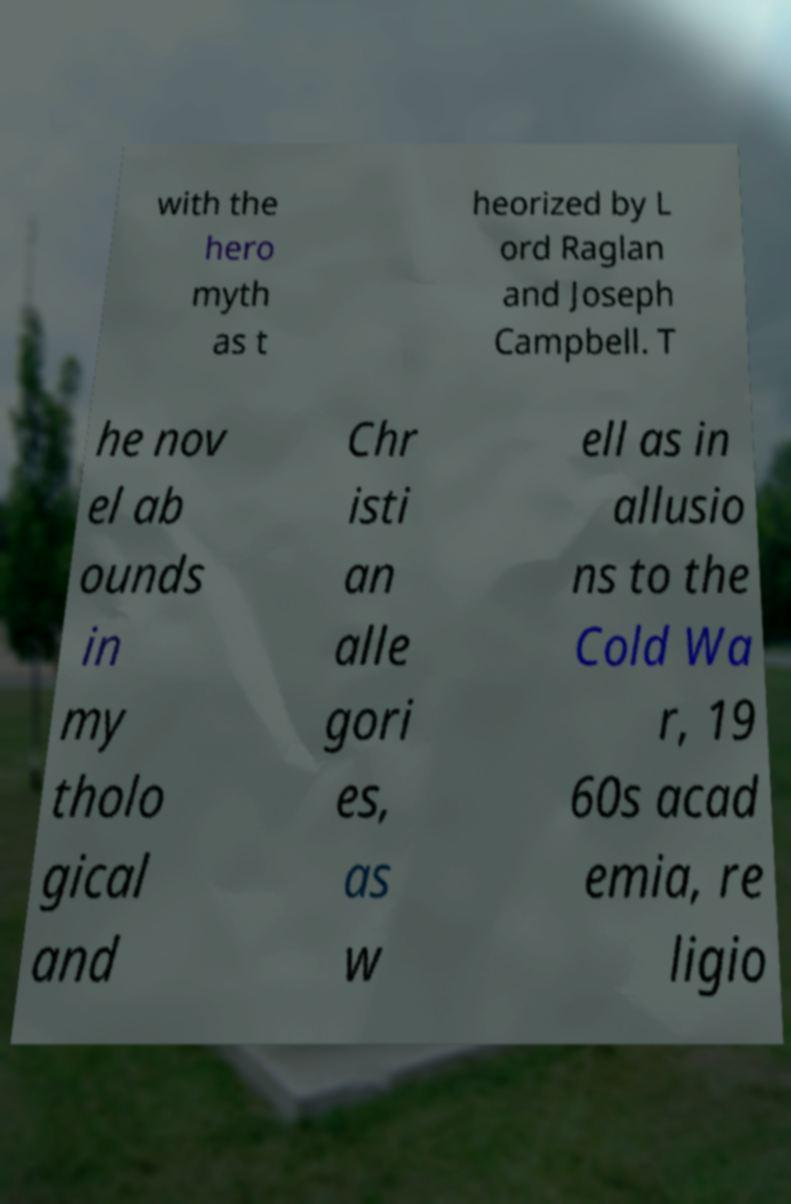I need the written content from this picture converted into text. Can you do that? with the hero myth as t heorized by L ord Raglan and Joseph Campbell. T he nov el ab ounds in my tholo gical and Chr isti an alle gori es, as w ell as in allusio ns to the Cold Wa r, 19 60s acad emia, re ligio 